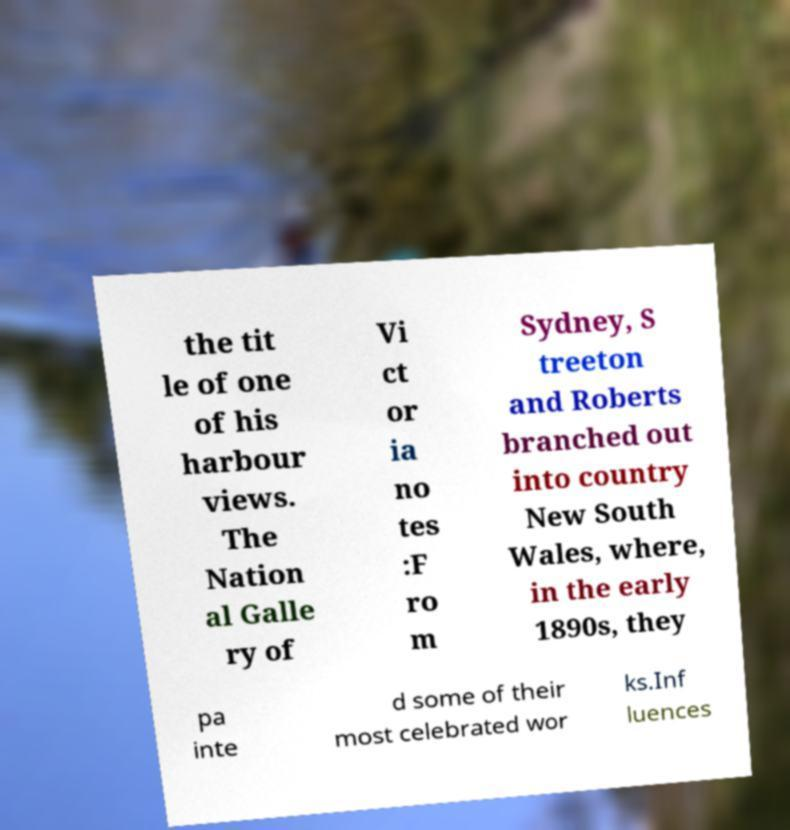For documentation purposes, I need the text within this image transcribed. Could you provide that? the tit le of one of his harbour views. The Nation al Galle ry of Vi ct or ia no tes :F ro m Sydney, S treeton and Roberts branched out into country New South Wales, where, in the early 1890s, they pa inte d some of their most celebrated wor ks.Inf luences 